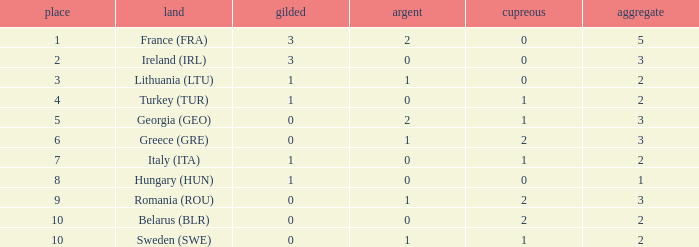What are the most bronze medals in a rank more than 1 with a total larger than 3? None. Would you be able to parse every entry in this table? {'header': ['place', 'land', 'gilded', 'argent', 'cupreous', 'aggregate'], 'rows': [['1', 'France (FRA)', '3', '2', '0', '5'], ['2', 'Ireland (IRL)', '3', '0', '0', '3'], ['3', 'Lithuania (LTU)', '1', '1', '0', '2'], ['4', 'Turkey (TUR)', '1', '0', '1', '2'], ['5', 'Georgia (GEO)', '0', '2', '1', '3'], ['6', 'Greece (GRE)', '0', '1', '2', '3'], ['7', 'Italy (ITA)', '1', '0', '1', '2'], ['8', 'Hungary (HUN)', '1', '0', '0', '1'], ['9', 'Romania (ROU)', '0', '1', '2', '3'], ['10', 'Belarus (BLR)', '0', '0', '2', '2'], ['10', 'Sweden (SWE)', '0', '1', '1', '2']]} 